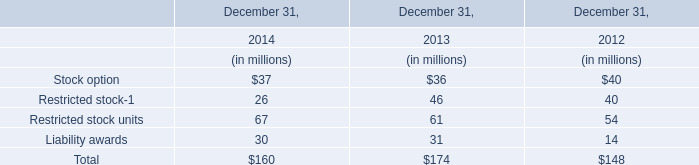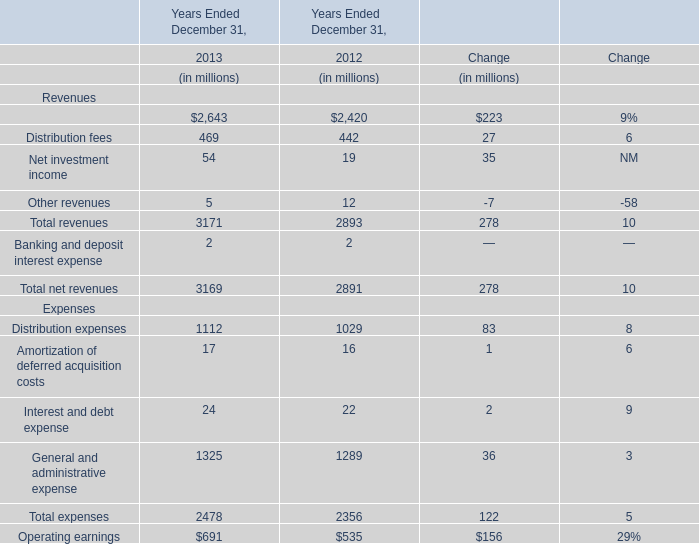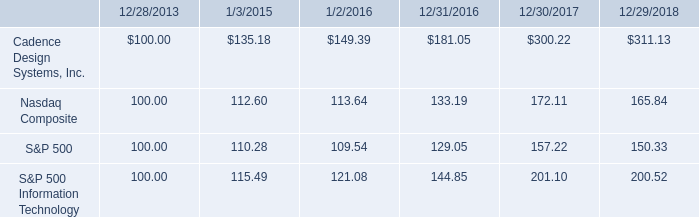In the year with largest amount of Management and financial advice fees, what's the sum of revenues? (in million) 
Computations: (((2643 + 469) + 54) + 5)
Answer: 3171.0. 